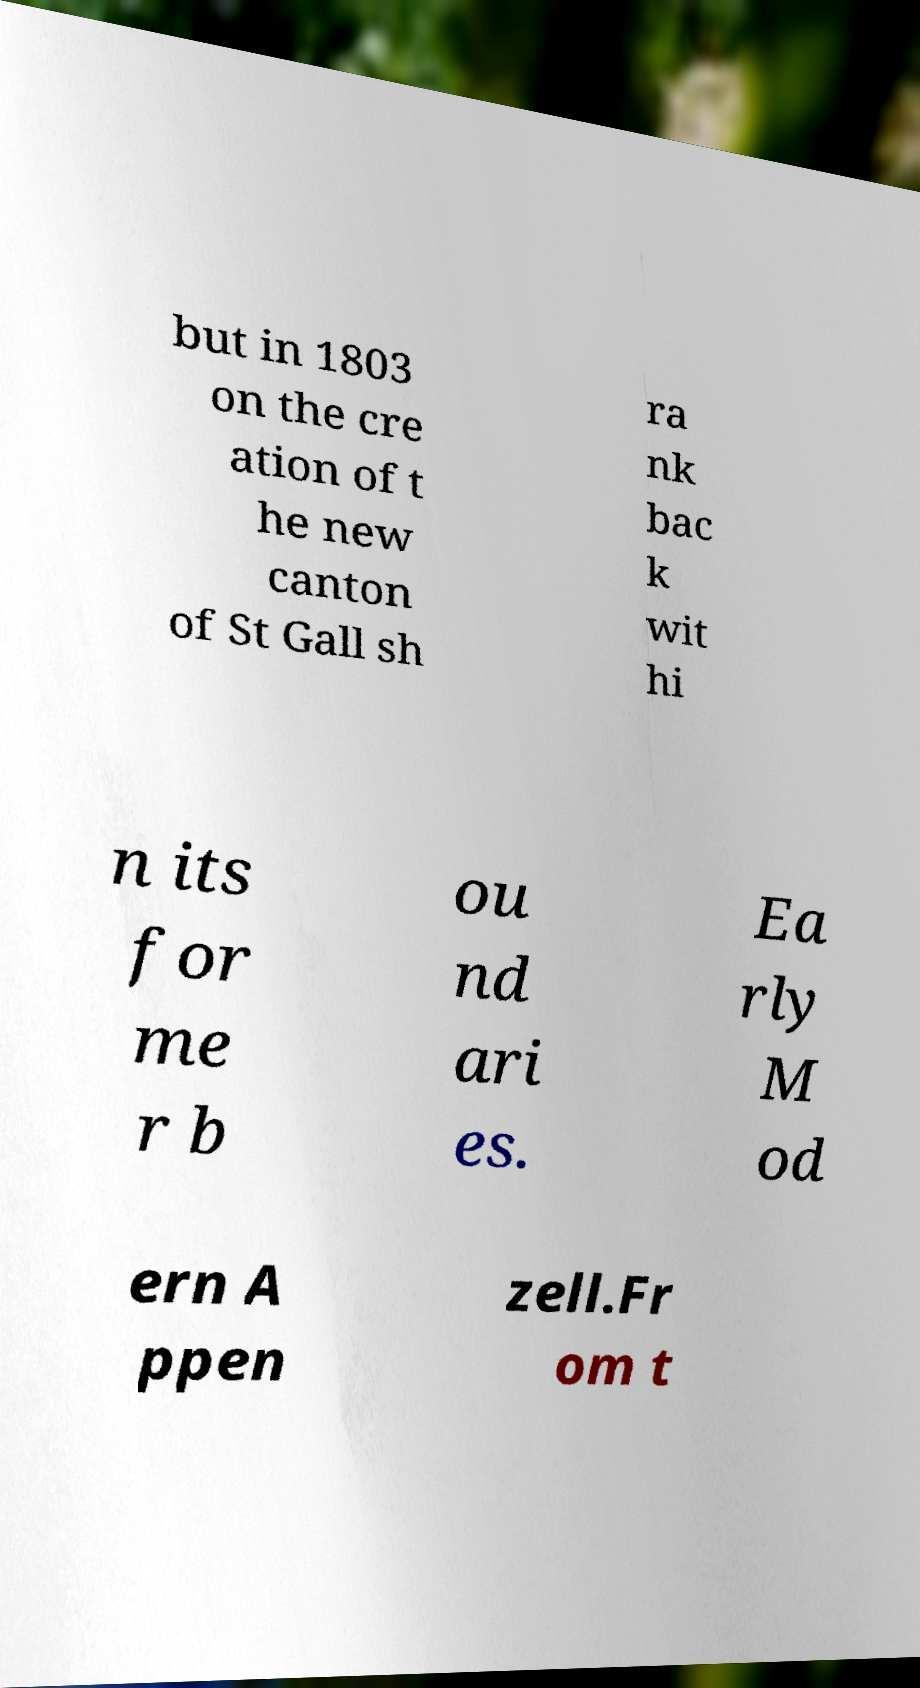There's text embedded in this image that I need extracted. Can you transcribe it verbatim? but in 1803 on the cre ation of t he new canton of St Gall sh ra nk bac k wit hi n its for me r b ou nd ari es. Ea rly M od ern A ppen zell.Fr om t 